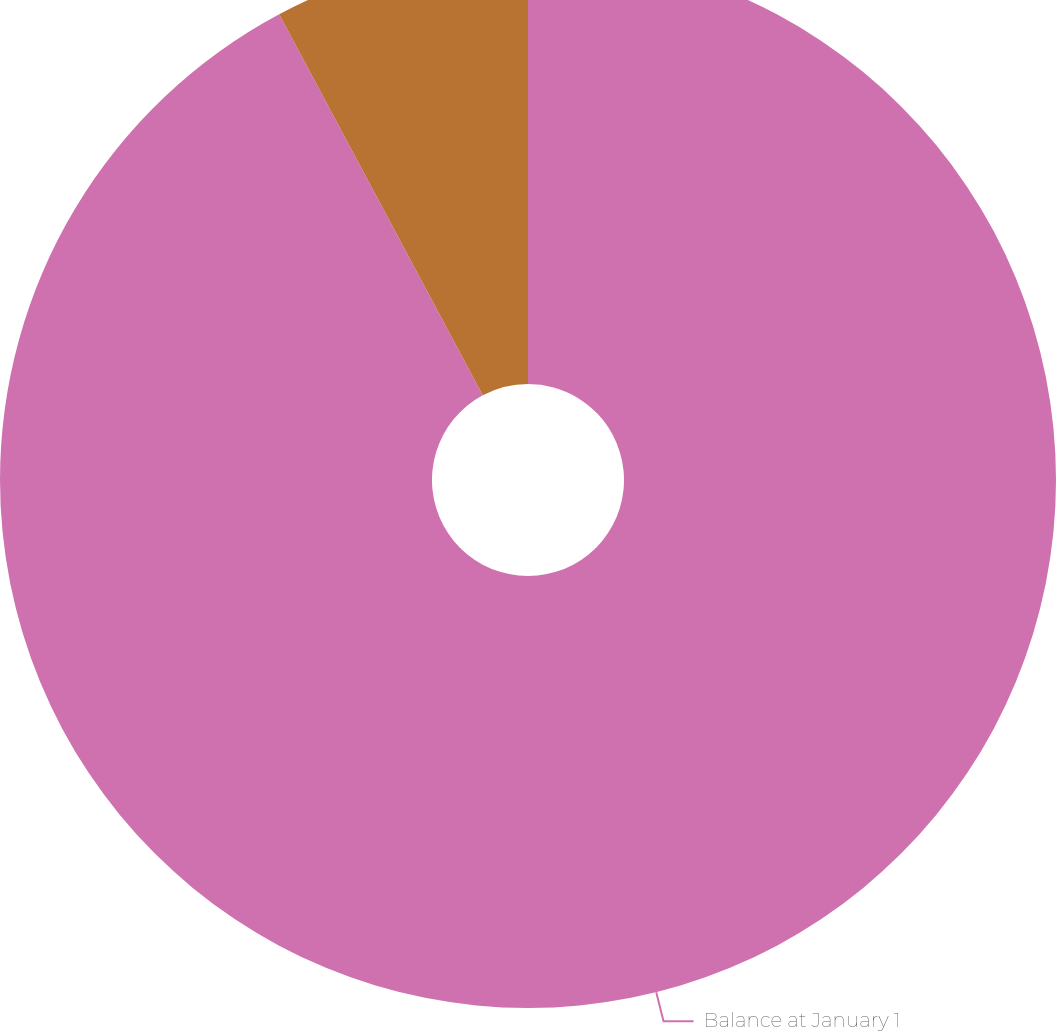Convert chart. <chart><loc_0><loc_0><loc_500><loc_500><pie_chart><fcel>Balance at January 1<fcel>Actual return on plan assets<nl><fcel>92.19%<fcel>7.81%<nl></chart> 